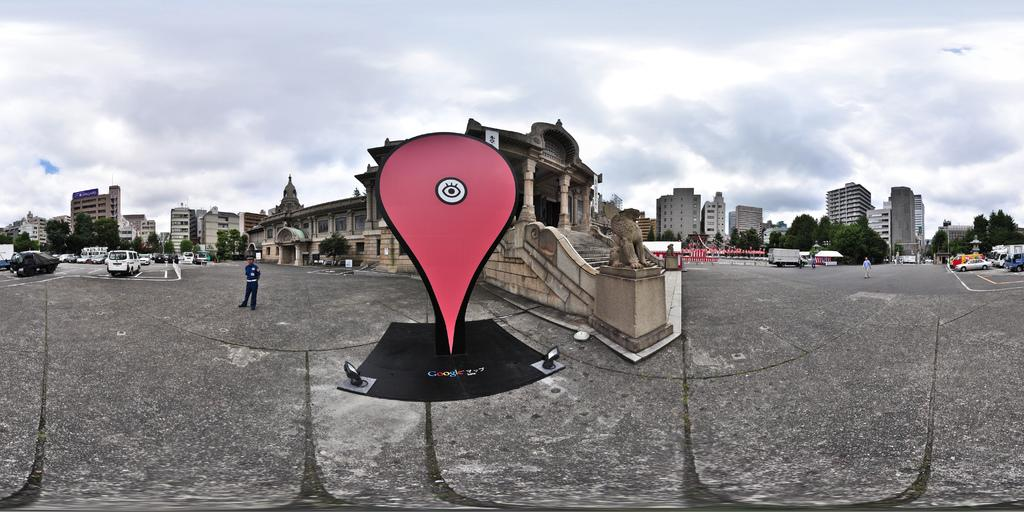What are the people in the image doing? The persons standing on the road are likely waiting or walking. What else can be seen on the road besides the people? Motor vehicles are present on the road. What type of natural elements can be seen in the image? There are trees in the image. What type of man-made structures are visible in the image? Buildings are visible in the image. What type of artistic elements can be seen in the image? Statues are present in the image, and they are likely placed on pedestals. What is visible in the sky in the image? The sky is visible in the image, and clouds are present. What type of sack is being used to stop the traffic in the image? There is no sack or traffic control device present in the image. What position is the statue in the image? The position of the statue cannot be determined from the image alone, as it depends on the statue's design and orientation. 